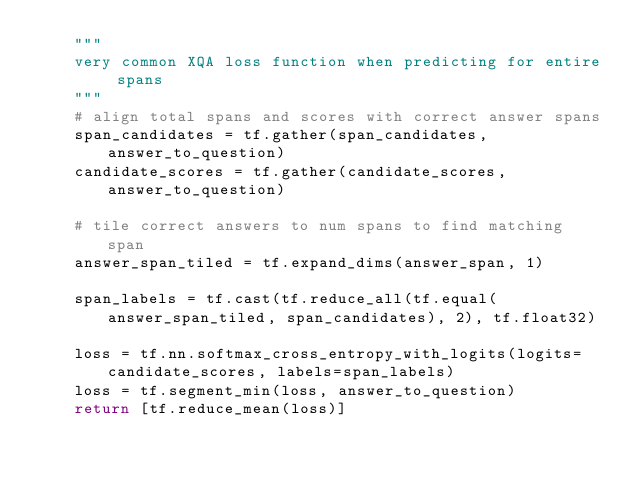Convert code to text. <code><loc_0><loc_0><loc_500><loc_500><_Python_>    """
    very common XQA loss function when predicting for entire spans
    """
    # align total spans and scores with correct answer spans
    span_candidates = tf.gather(span_candidates, answer_to_question)
    candidate_scores = tf.gather(candidate_scores, answer_to_question)

    # tile correct answers to num spans to find matching span
    answer_span_tiled = tf.expand_dims(answer_span, 1)

    span_labels = tf.cast(tf.reduce_all(tf.equal(answer_span_tiled, span_candidates), 2), tf.float32)

    loss = tf.nn.softmax_cross_entropy_with_logits(logits=candidate_scores, labels=span_labels)
    loss = tf.segment_min(loss, answer_to_question)
    return [tf.reduce_mean(loss)]</code> 